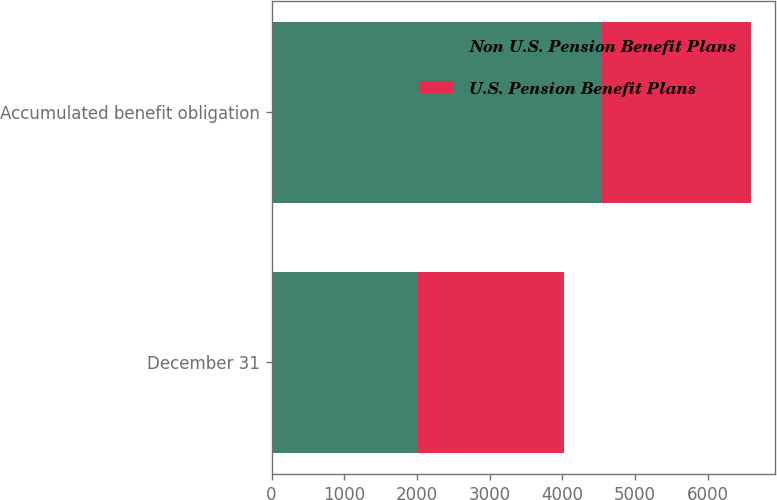<chart> <loc_0><loc_0><loc_500><loc_500><stacked_bar_chart><ecel><fcel>December 31<fcel>Accumulated benefit obligation<nl><fcel>Non U.S. Pension Benefit Plans<fcel>2014<fcel>4536<nl><fcel>U.S. Pension Benefit Plans<fcel>2014<fcel>2059<nl></chart> 